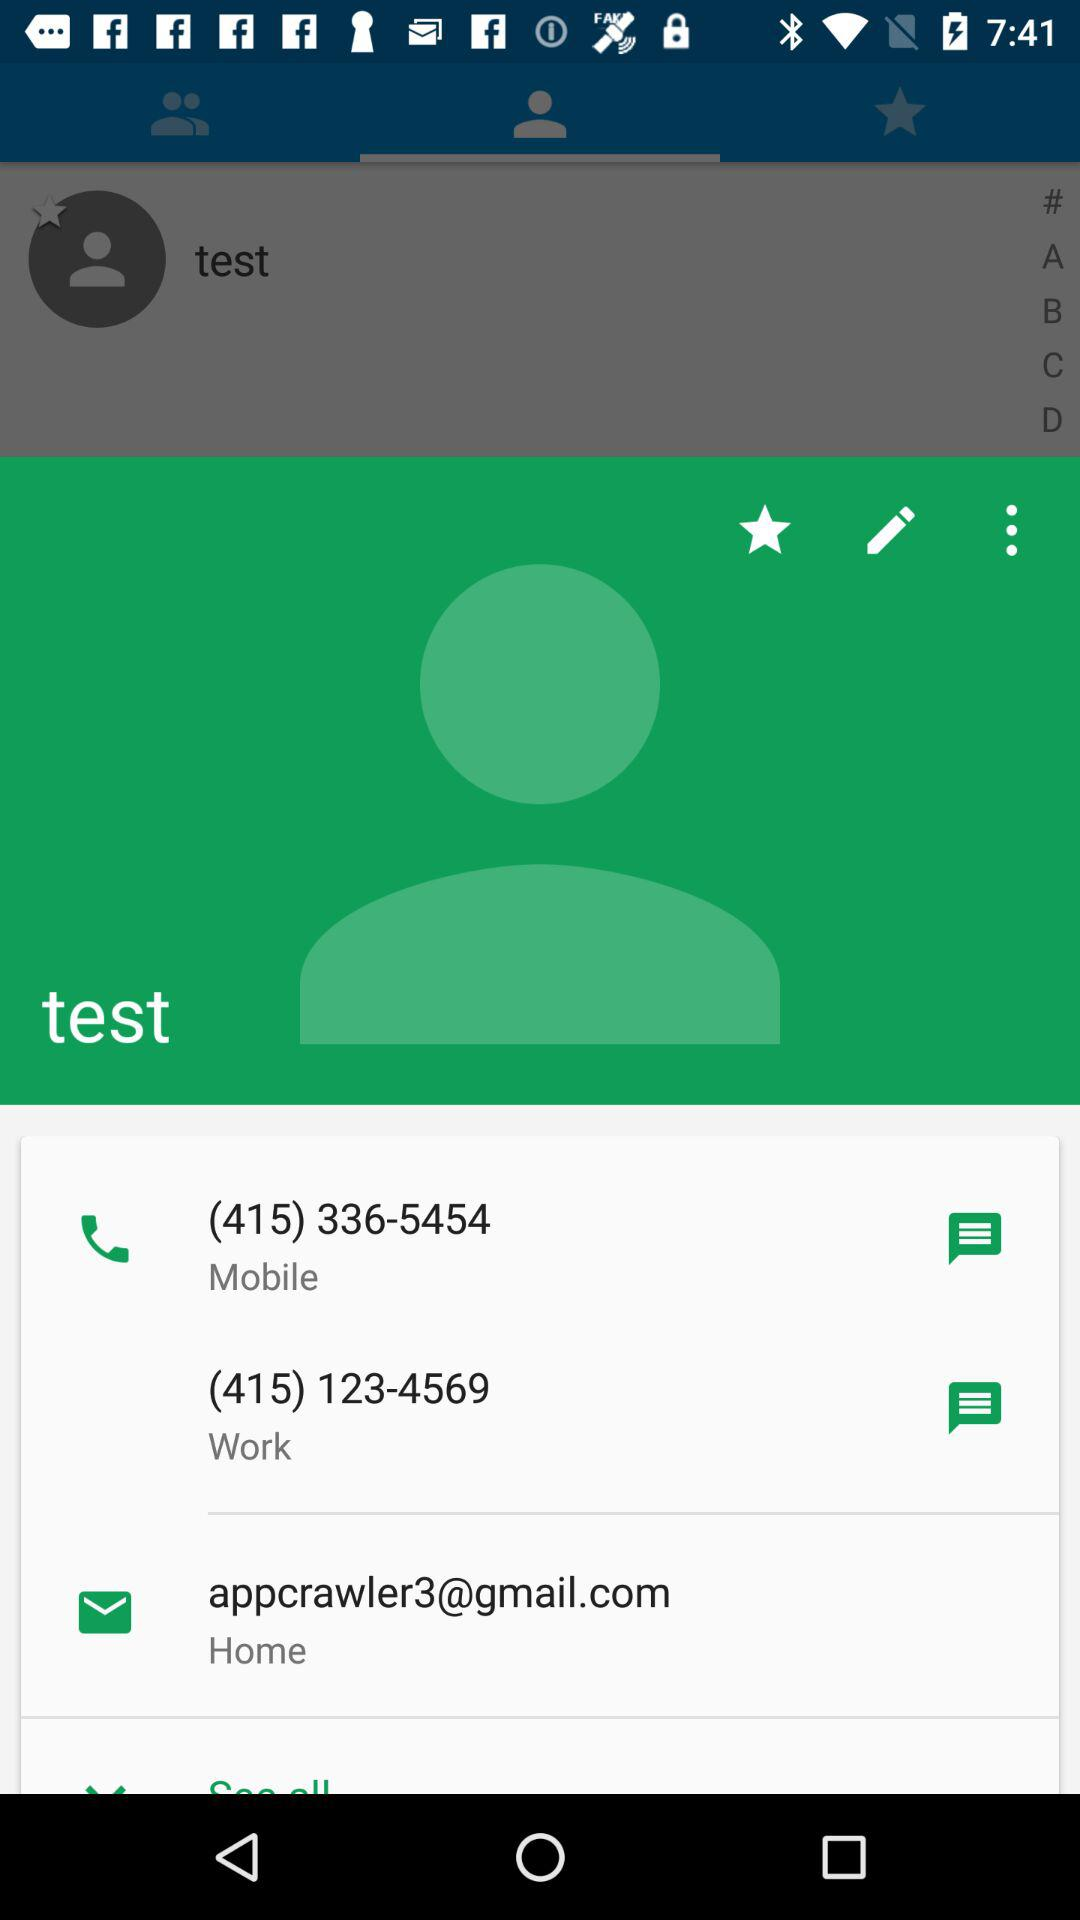What contacts are listed in A?
When the provided information is insufficient, respond with <no answer>. <no answer> 